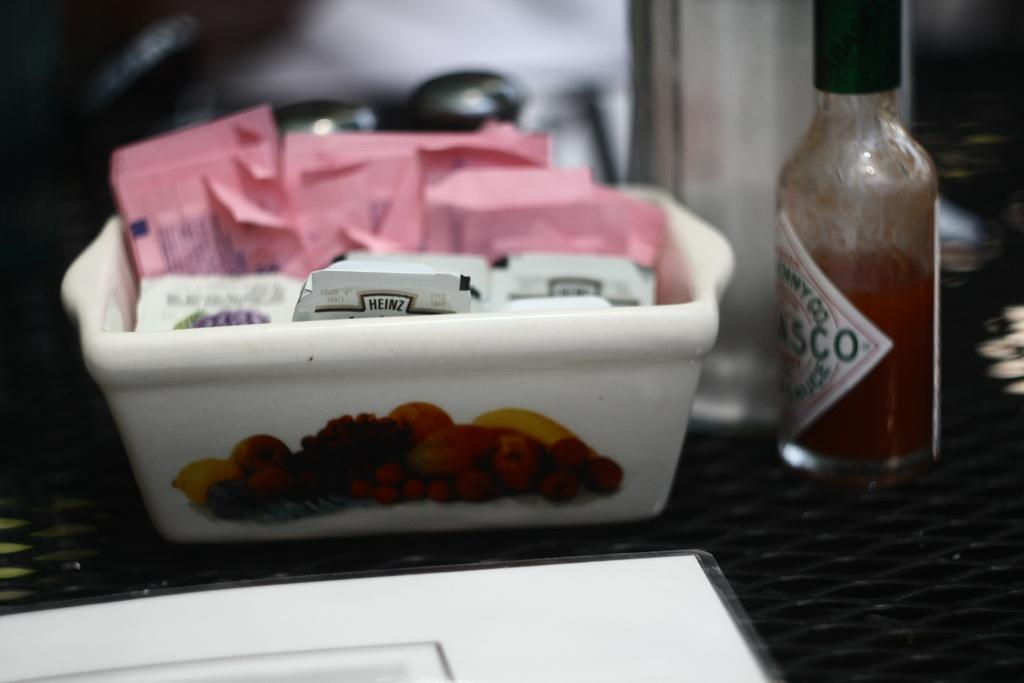Provide a one-sentence caption for the provided image. A container that has sugar and jam from the brand Heinz. 